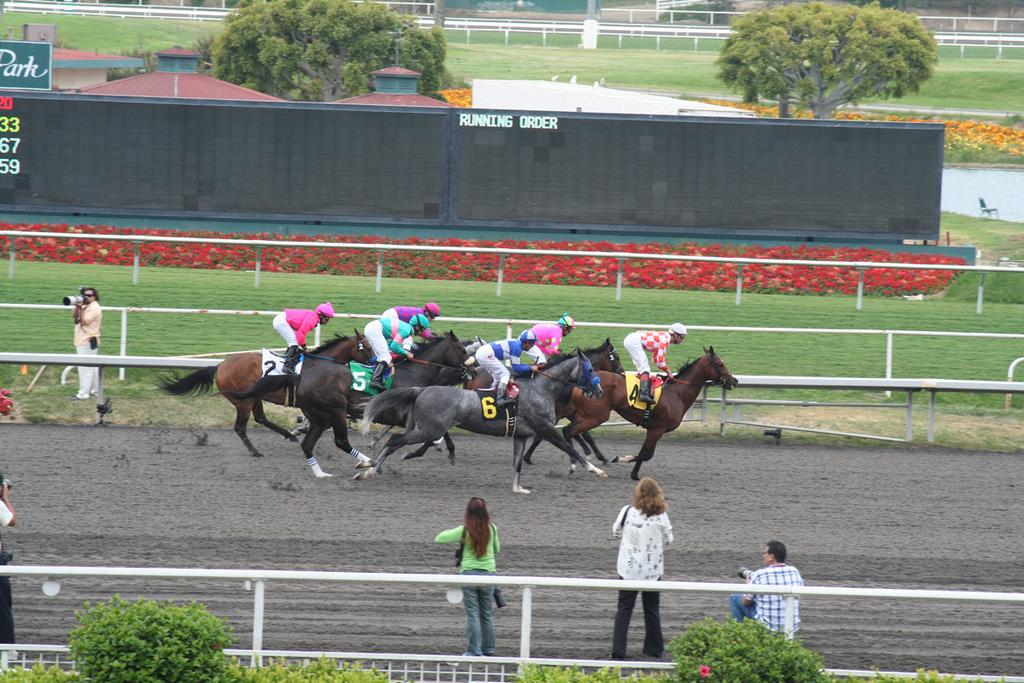What activity is the horse engaged in within the image? The horse is racing in the image. Are there any people present in the image? Yes, there are people in the image. What structures can be seen in the image? There are barriers, boards, a fence, and roofs for shelter in the image. What type of natural environment is depicted in the image? The image features trees, grass, and plants. What type of path is visible in the image? There is a path in the image. What type of watch can be seen on the horse's leg in the image? There is no watch present on the horse's leg in the image. Can you see a turkey running alongside the horse in the image? There is no turkey present in the image; it only features a horse racing. Is there a band playing music in the background of the image? There is no band playing music in the background of the image. 